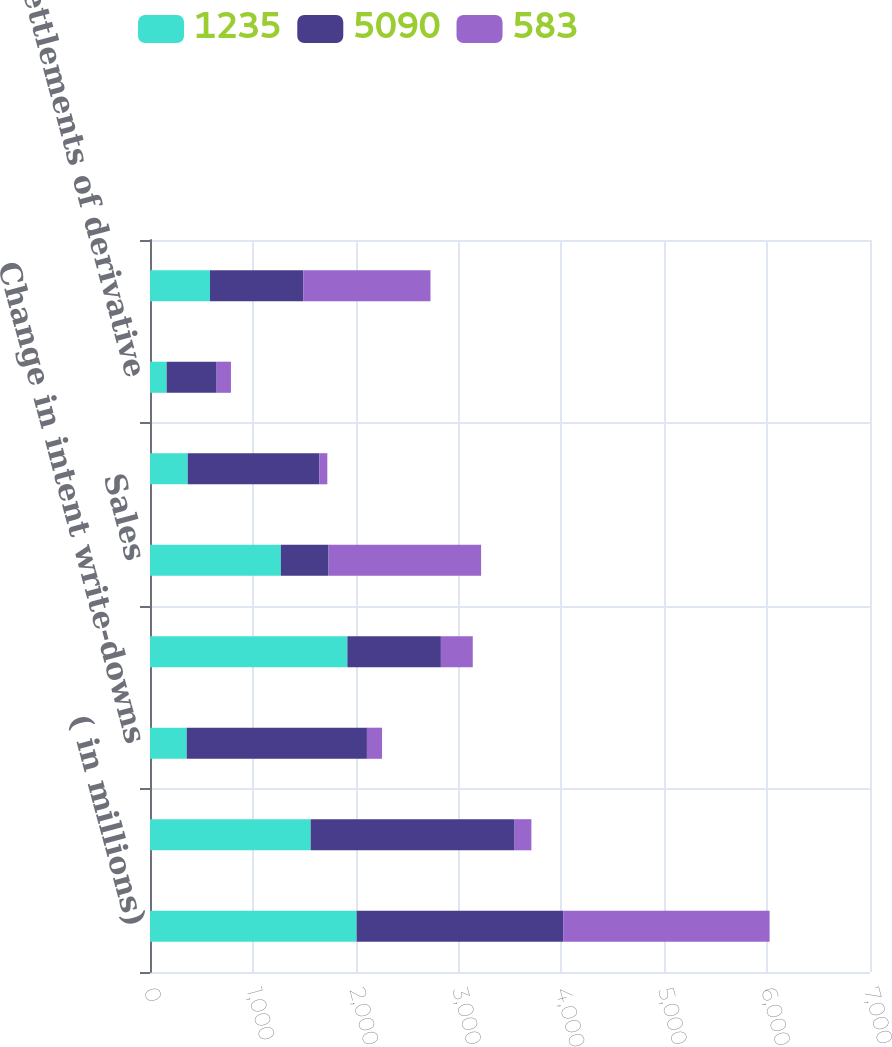Convert chart. <chart><loc_0><loc_0><loc_500><loc_500><stacked_bar_chart><ecel><fcel>( in millions)<fcel>Impairment write-downs (1)<fcel>Change in intent write-downs<fcel>Net OTTI losses recognized in<fcel>Sales<fcel>Valuation of derivative<fcel>Settlements of derivative<fcel>Realized capital gains and<nl><fcel>1235<fcel>2009<fcel>1562<fcel>357<fcel>1919<fcel>1272<fcel>367<fcel>162<fcel>583<nl><fcel>5090<fcel>2008<fcel>1983<fcel>1752<fcel>909<fcel>464<fcel>1280<fcel>486<fcel>909<nl><fcel>583<fcel>2007<fcel>163<fcel>147<fcel>310<fcel>1483<fcel>77<fcel>139<fcel>1235<nl></chart> 